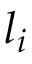<formula> <loc_0><loc_0><loc_500><loc_500>l _ { i }</formula> 